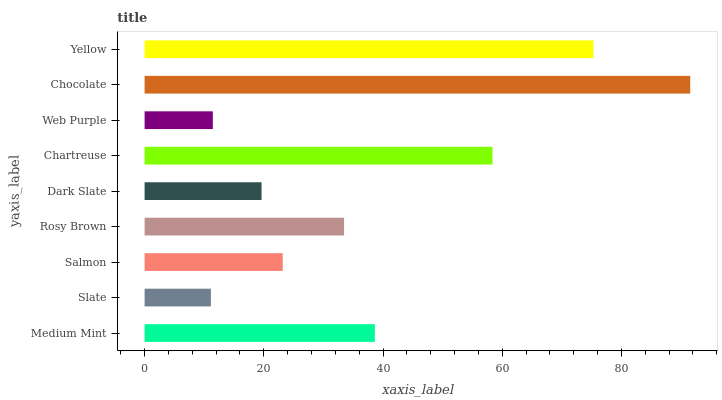Is Slate the minimum?
Answer yes or no. Yes. Is Chocolate the maximum?
Answer yes or no. Yes. Is Salmon the minimum?
Answer yes or no. No. Is Salmon the maximum?
Answer yes or no. No. Is Salmon greater than Slate?
Answer yes or no. Yes. Is Slate less than Salmon?
Answer yes or no. Yes. Is Slate greater than Salmon?
Answer yes or no. No. Is Salmon less than Slate?
Answer yes or no. No. Is Rosy Brown the high median?
Answer yes or no. Yes. Is Rosy Brown the low median?
Answer yes or no. Yes. Is Salmon the high median?
Answer yes or no. No. Is Medium Mint the low median?
Answer yes or no. No. 